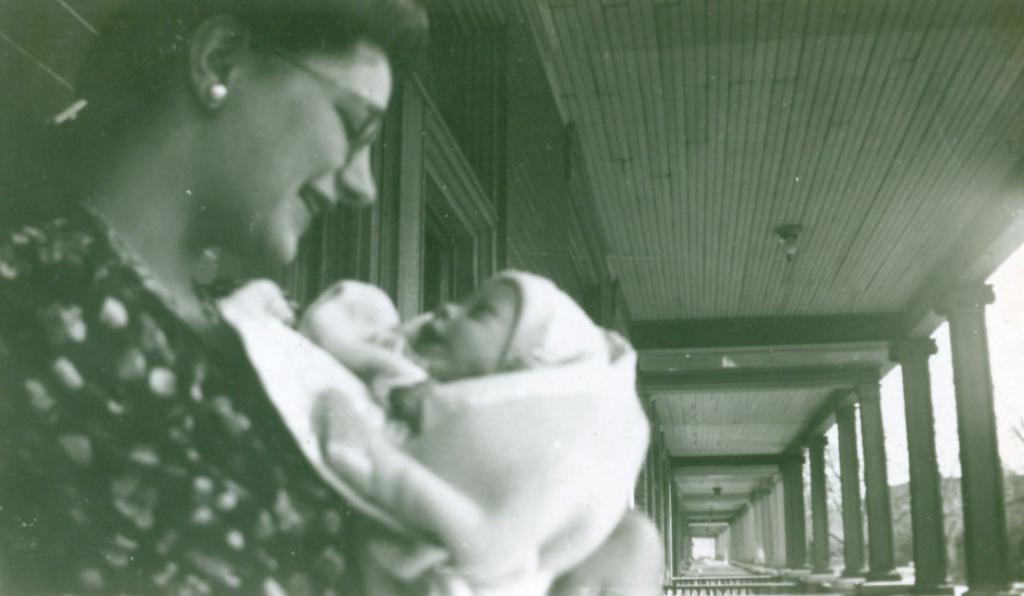Please provide a concise description of this image. In this black and white picture there is a woman holding a infant in her hand. She is smiling. Behind her there are pillars and a ceiling to the wall. To the right there is the sky. 